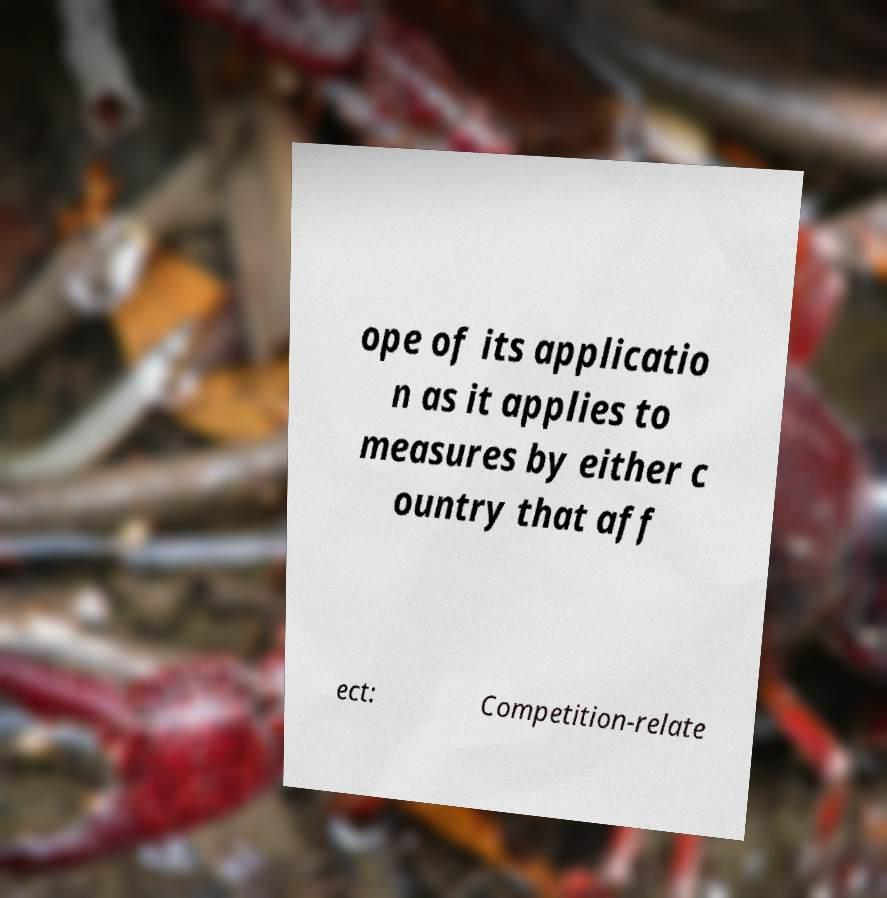There's text embedded in this image that I need extracted. Can you transcribe it verbatim? ope of its applicatio n as it applies to measures by either c ountry that aff ect: Competition-relate 